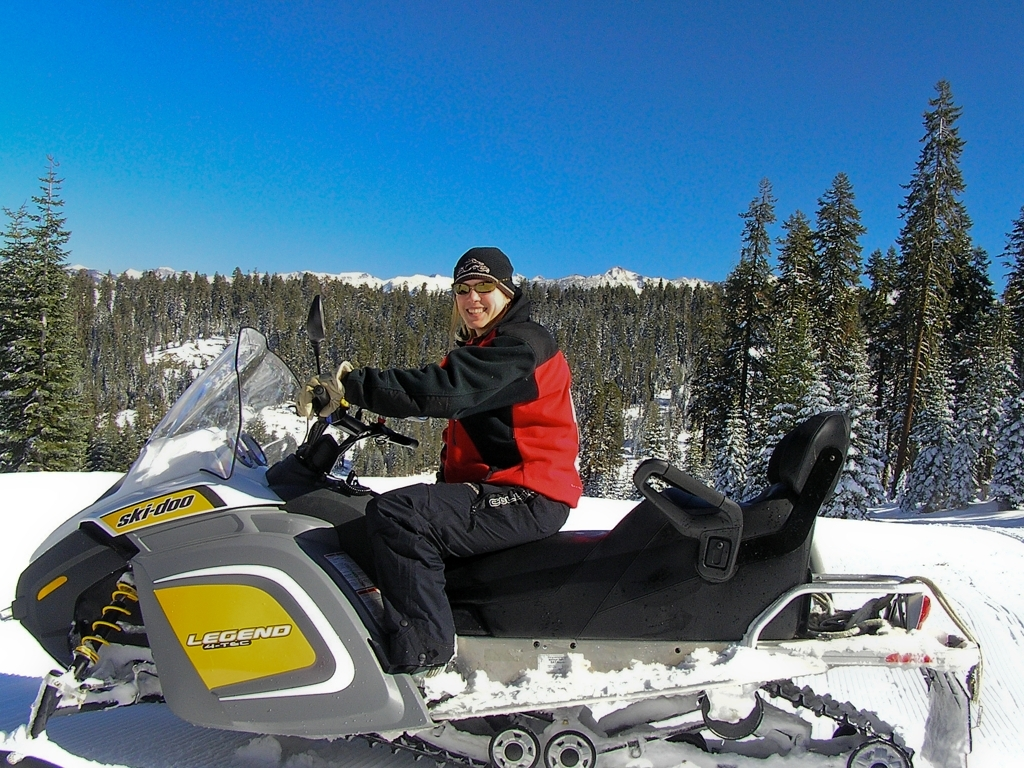What kind of safety equipment should be worn while riding a snowmobile? While riding a snowmobile, you should wear proper safety equipment such as a DOT-approved helmet, goggles for eye protection, insulated gloves, and footwear that can handle cold and wet conditions. It's also advisable to wear layers of water-resistant clothing to keep warm and dry. 